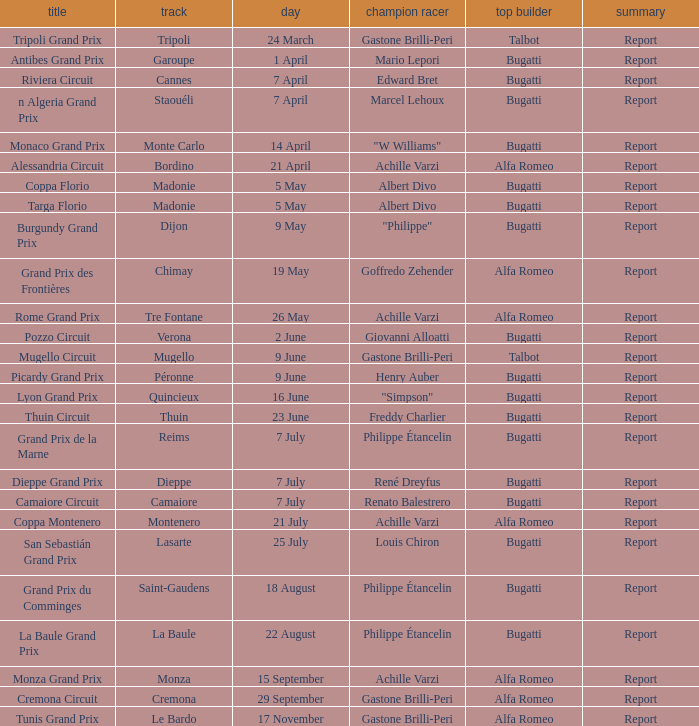What Winning driver has a Winning constructor of talbot? Gastone Brilli-Peri, Gastone Brilli-Peri. 